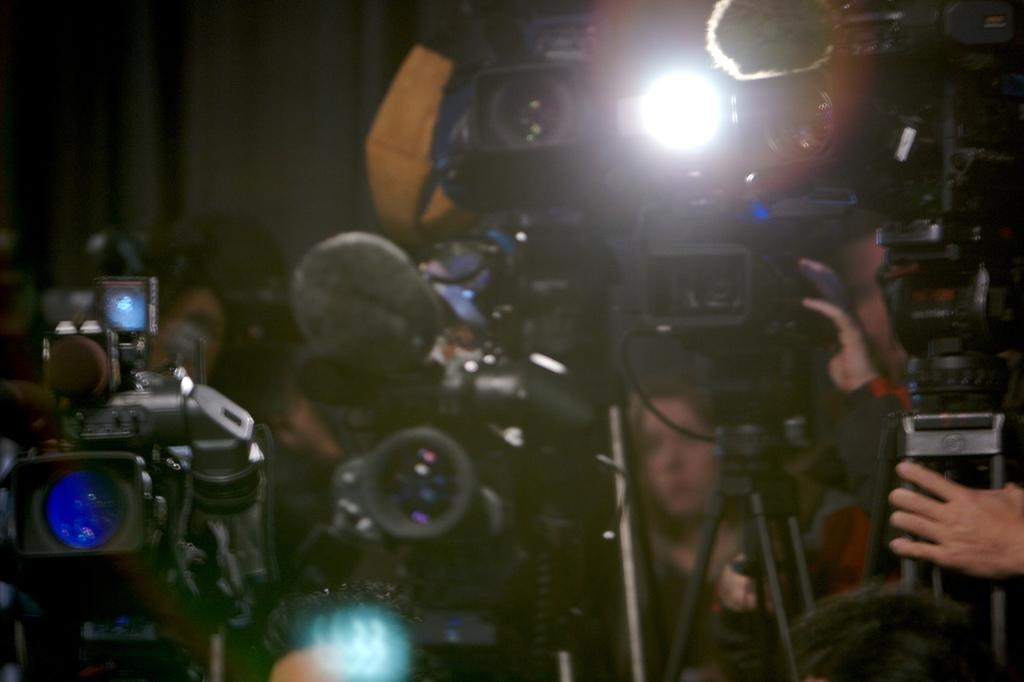What objects are visible in the image? There are cameras in the image. How are the cameras positioned in the image? The cameras are placed on a stand. Are there any people present in the image? Yes, there are people behind the cameras. What type of stretch can be seen on the cameras in the image? There is no stretch visible on the cameras in the image. 